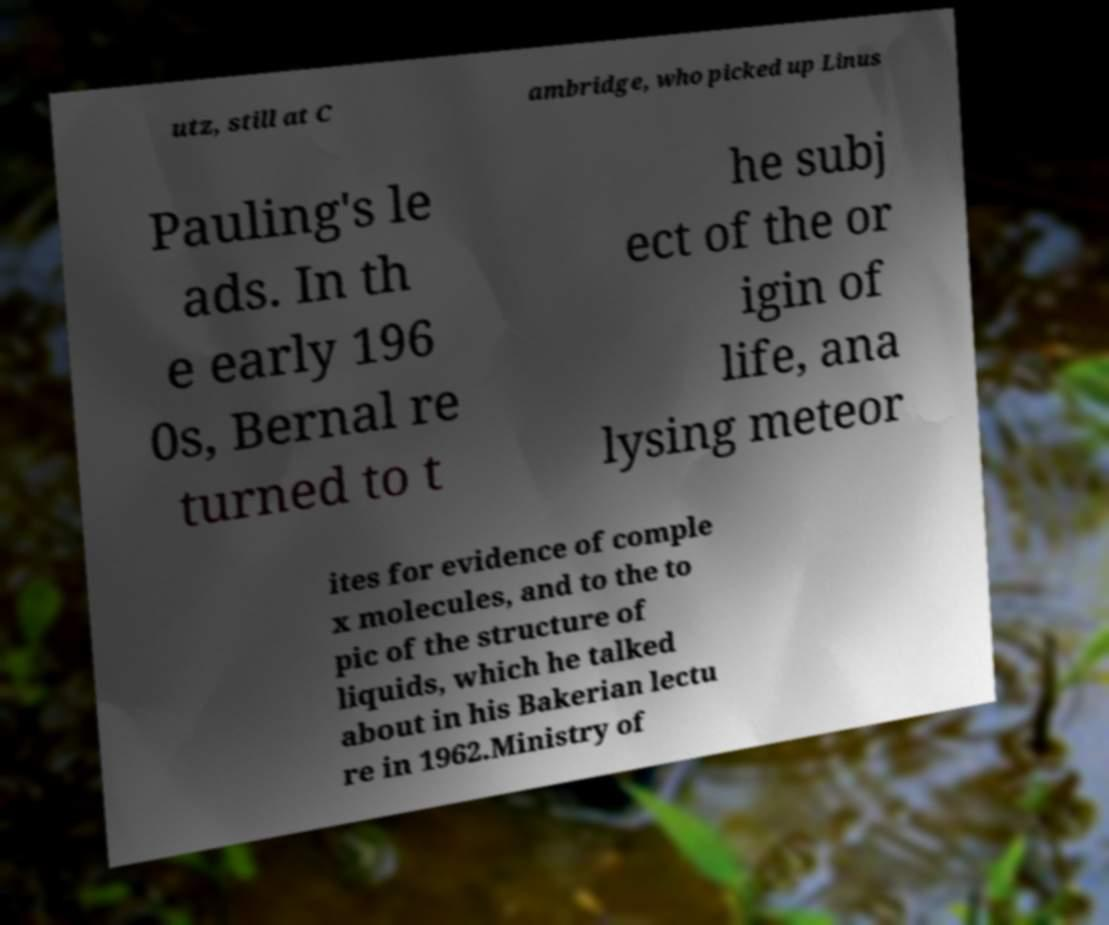Could you assist in decoding the text presented in this image and type it out clearly? utz, still at C ambridge, who picked up Linus Pauling's le ads. In th e early 196 0s, Bernal re turned to t he subj ect of the or igin of life, ana lysing meteor ites for evidence of comple x molecules, and to the to pic of the structure of liquids, which he talked about in his Bakerian lectu re in 1962.Ministry of 